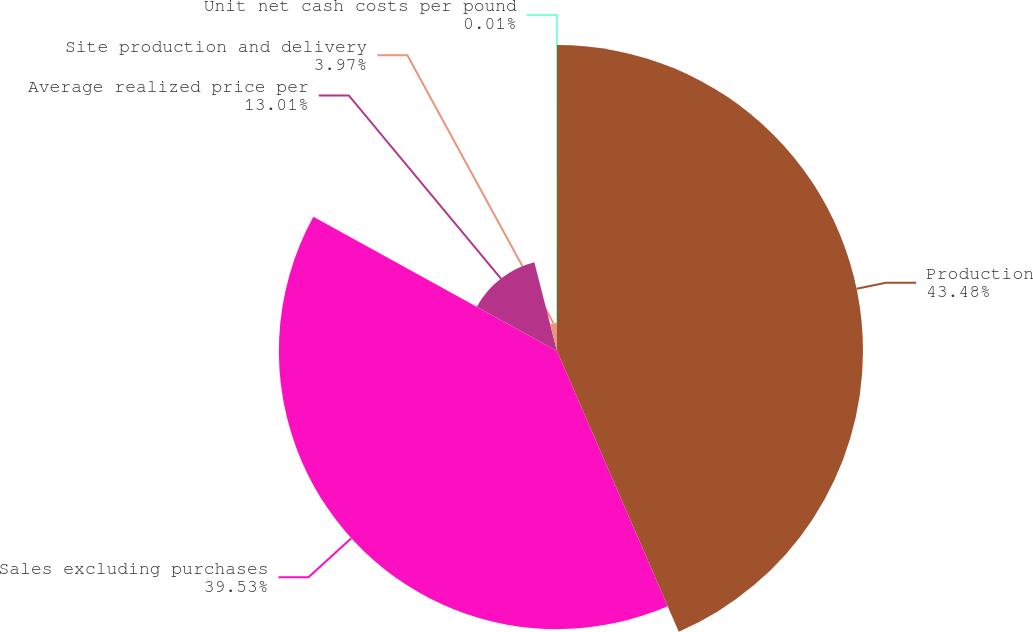Convert chart to OTSL. <chart><loc_0><loc_0><loc_500><loc_500><pie_chart><fcel>Production<fcel>Sales excluding purchases<fcel>Average realized price per<fcel>Site production and delivery<fcel>Unit net cash costs per pound<nl><fcel>43.49%<fcel>39.53%<fcel>13.01%<fcel>3.97%<fcel>0.01%<nl></chart> 